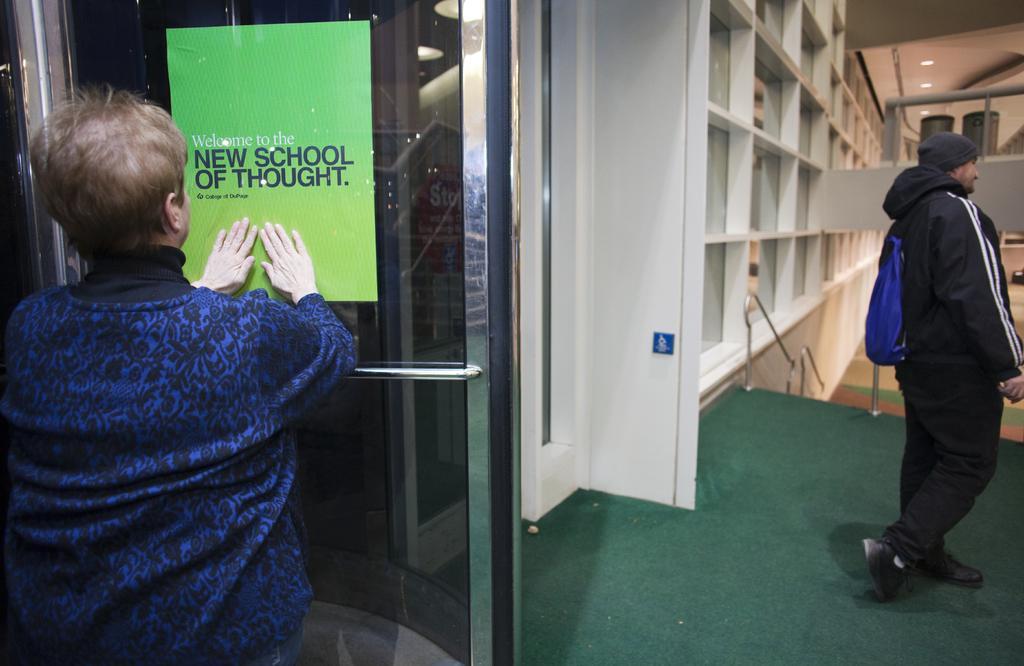How would you summarize this image in a sentence or two? In this picture there is an old woman wearing a blue sweater is sticking a green paper on the glass door. Behind we can see a man wearing black jacket is standing. In the background there are some white color lockers. 